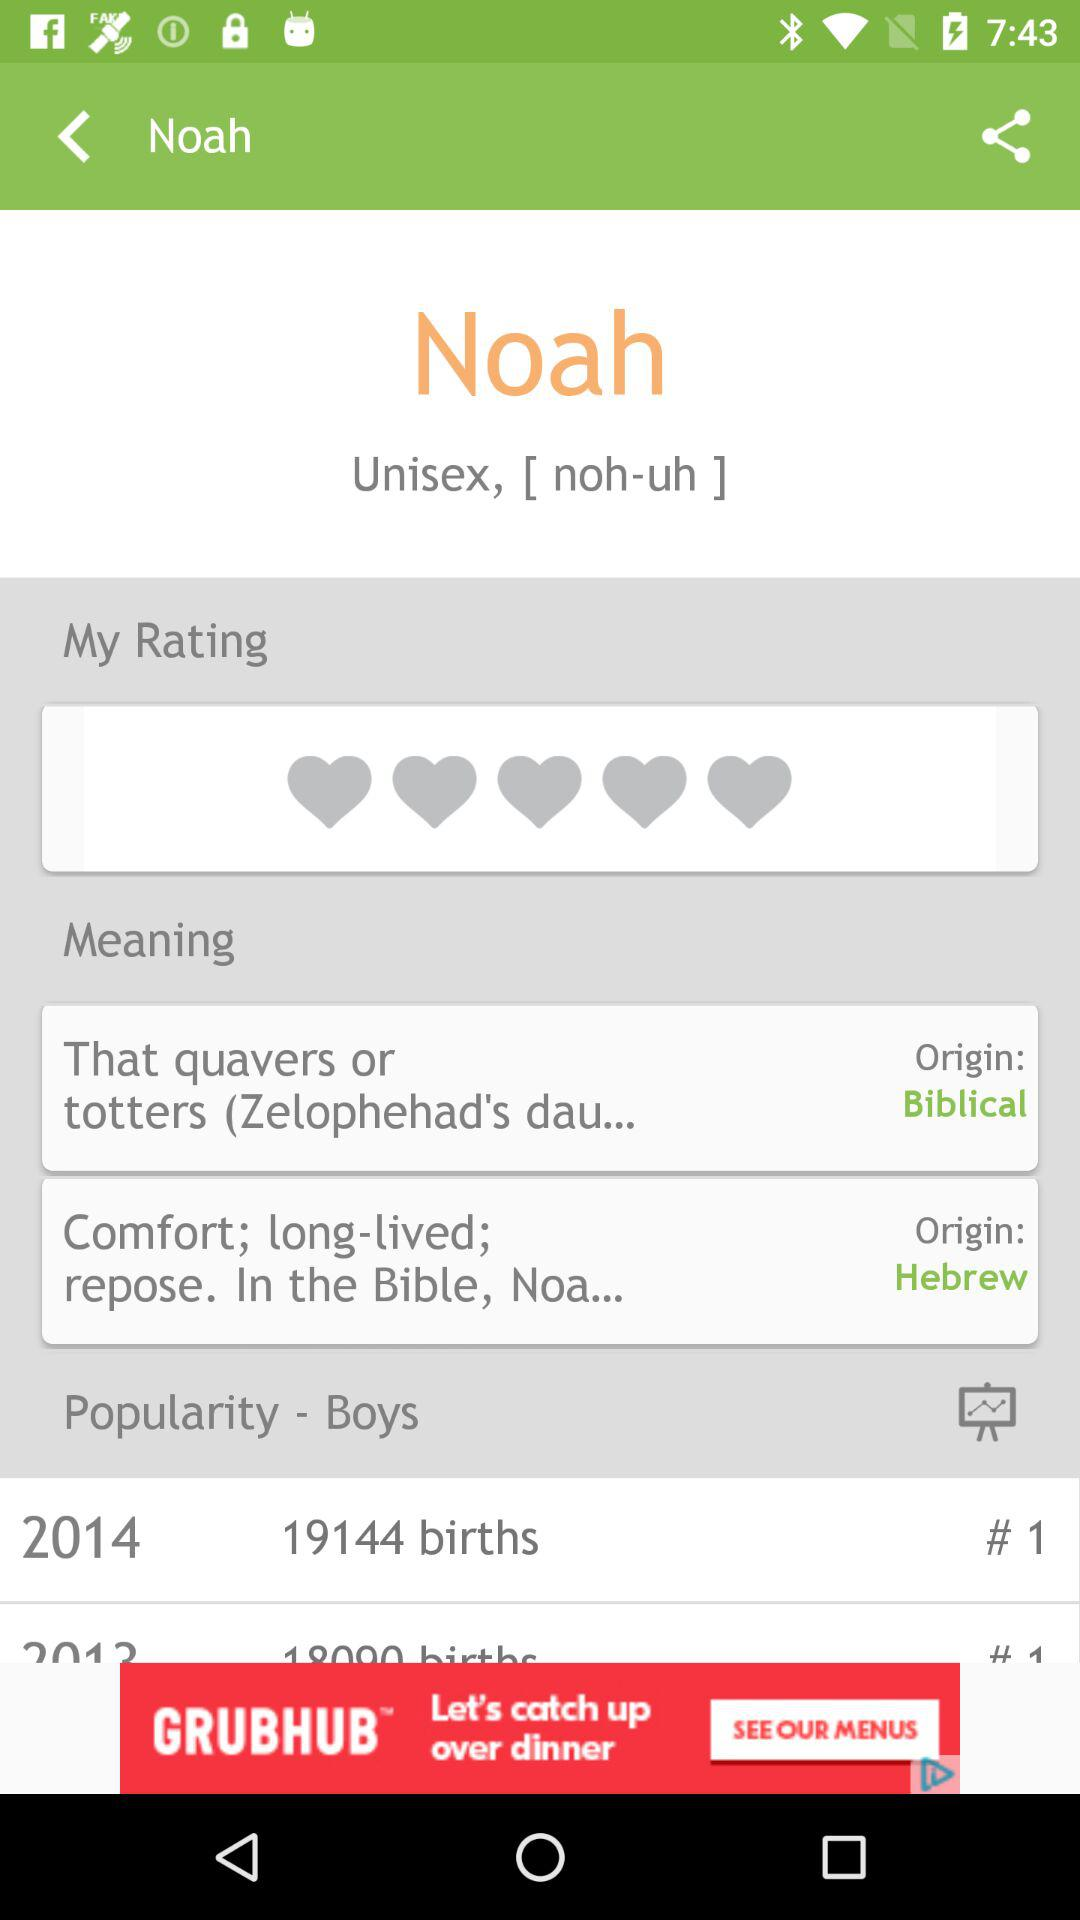How many more births were there in 2014 than in 2012 for the name Noah?
Answer the question using a single word or phrase. 1144 